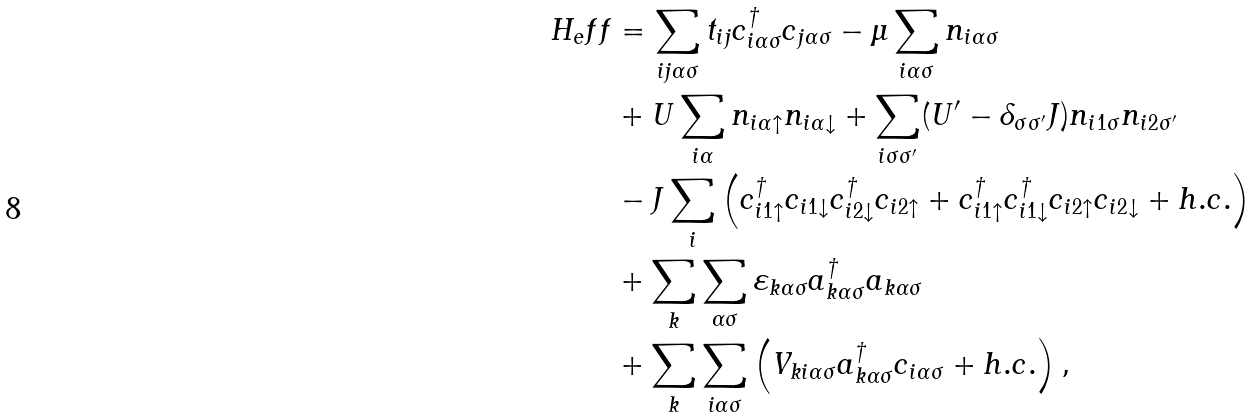<formula> <loc_0><loc_0><loc_500><loc_500>H _ { e } f f & = \sum _ { i j \alpha \sigma } t _ { i j } c _ { i \alpha \sigma } ^ { \dag } c _ { j \alpha \sigma } - \mu \sum _ { i \alpha \sigma } n _ { i \alpha \sigma } \\ & + U \sum _ { i \alpha } n _ { i \alpha \uparrow } n _ { i \alpha \downarrow } + \sum _ { i \sigma \sigma ^ { \prime } } ( U ^ { \prime } - \delta _ { \sigma \sigma ^ { \prime } } J ) n _ { i 1 \sigma } n _ { i 2 \sigma ^ { \prime } } \\ & - J \sum _ { i } \left ( c _ { i 1 \uparrow } ^ { \dag } c _ { i 1 \downarrow } c _ { i 2 \downarrow } ^ { \dag } c _ { i 2 \uparrow } + c _ { i 1 \uparrow } ^ { \dag } c _ { i 1 \downarrow } ^ { \dag } c _ { i 2 \uparrow } c _ { i 2 \downarrow } + h . c . \right ) \\ & + \sum _ { k } \sum _ { \alpha \sigma } \varepsilon _ { k \alpha \sigma } a _ { k \alpha \sigma } ^ { \dag } a _ { k \alpha \sigma } \\ & + \sum _ { k } \sum _ { i \alpha \sigma } \left ( V _ { k i \alpha \sigma } a _ { k \alpha \sigma } ^ { \dag } c _ { i \alpha \sigma } + h . c . \right ) ,</formula> 